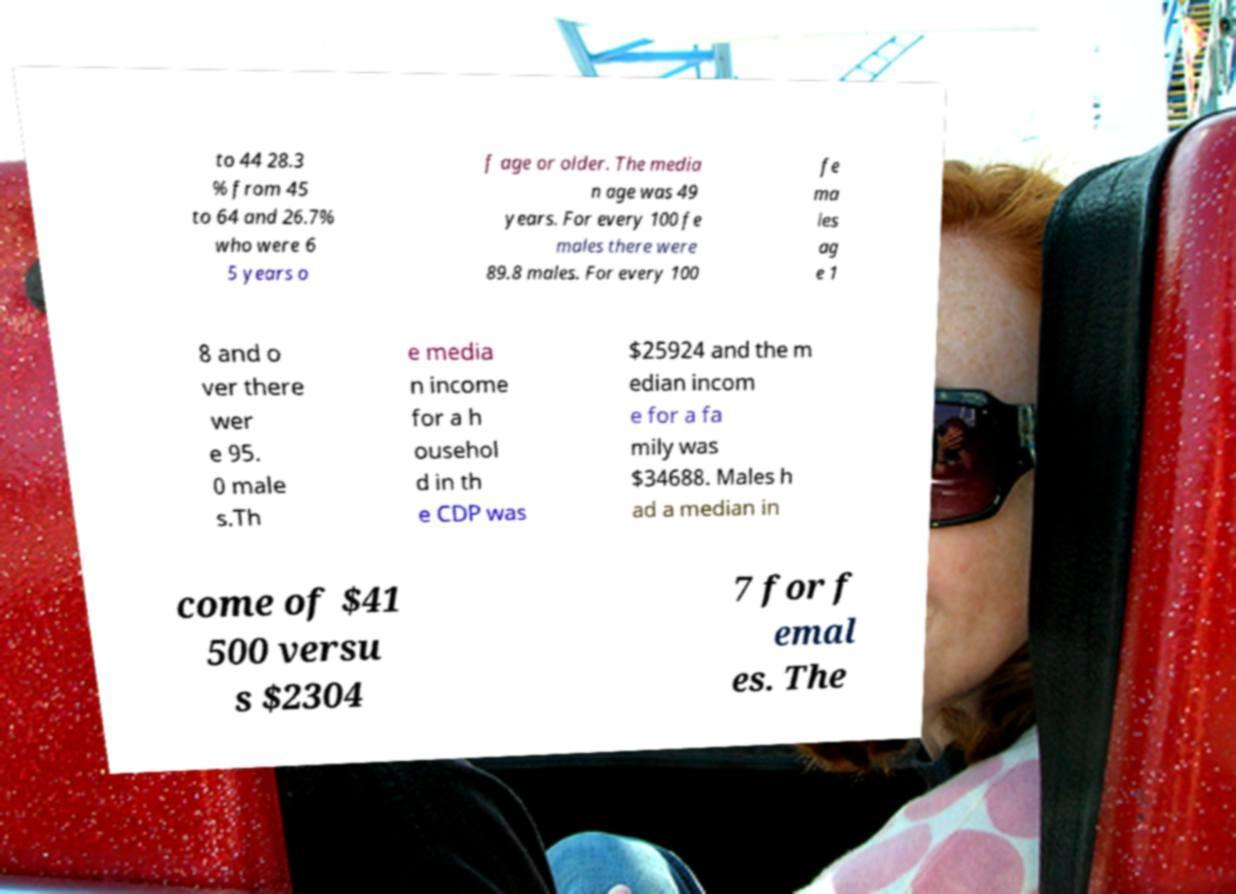Could you extract and type out the text from this image? to 44 28.3 % from 45 to 64 and 26.7% who were 6 5 years o f age or older. The media n age was 49 years. For every 100 fe males there were 89.8 males. For every 100 fe ma les ag e 1 8 and o ver there wer e 95. 0 male s.Th e media n income for a h ousehol d in th e CDP was $25924 and the m edian incom e for a fa mily was $34688. Males h ad a median in come of $41 500 versu s $2304 7 for f emal es. The 